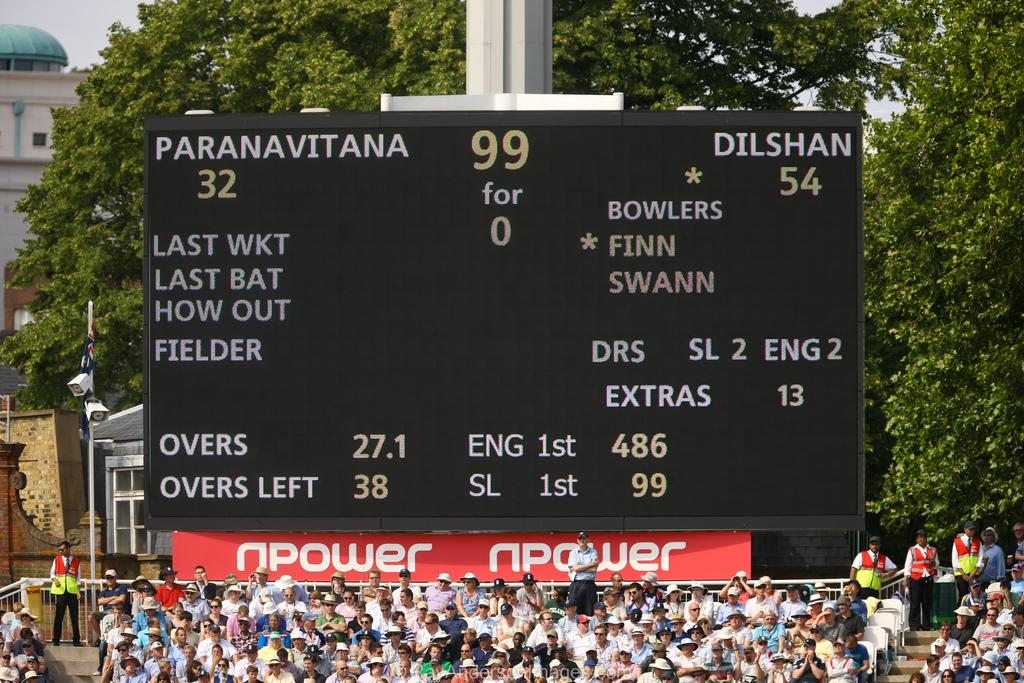<image>
Render a clear and concise summary of the photo. A scoreboard above a set of bleachers that says npower on the bottom of it. 